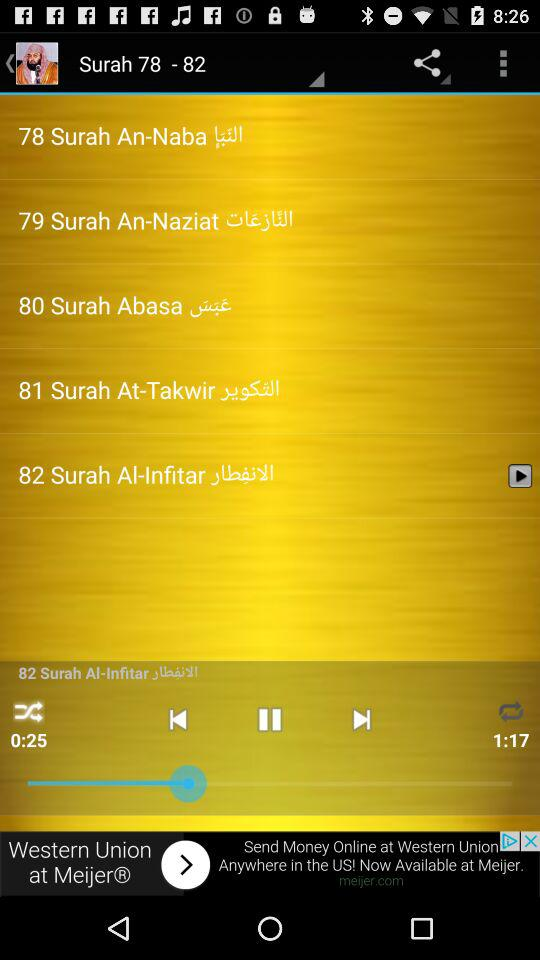What surah is playing now? The surah that is playing now is "82 Surah Al-Infitar la". 